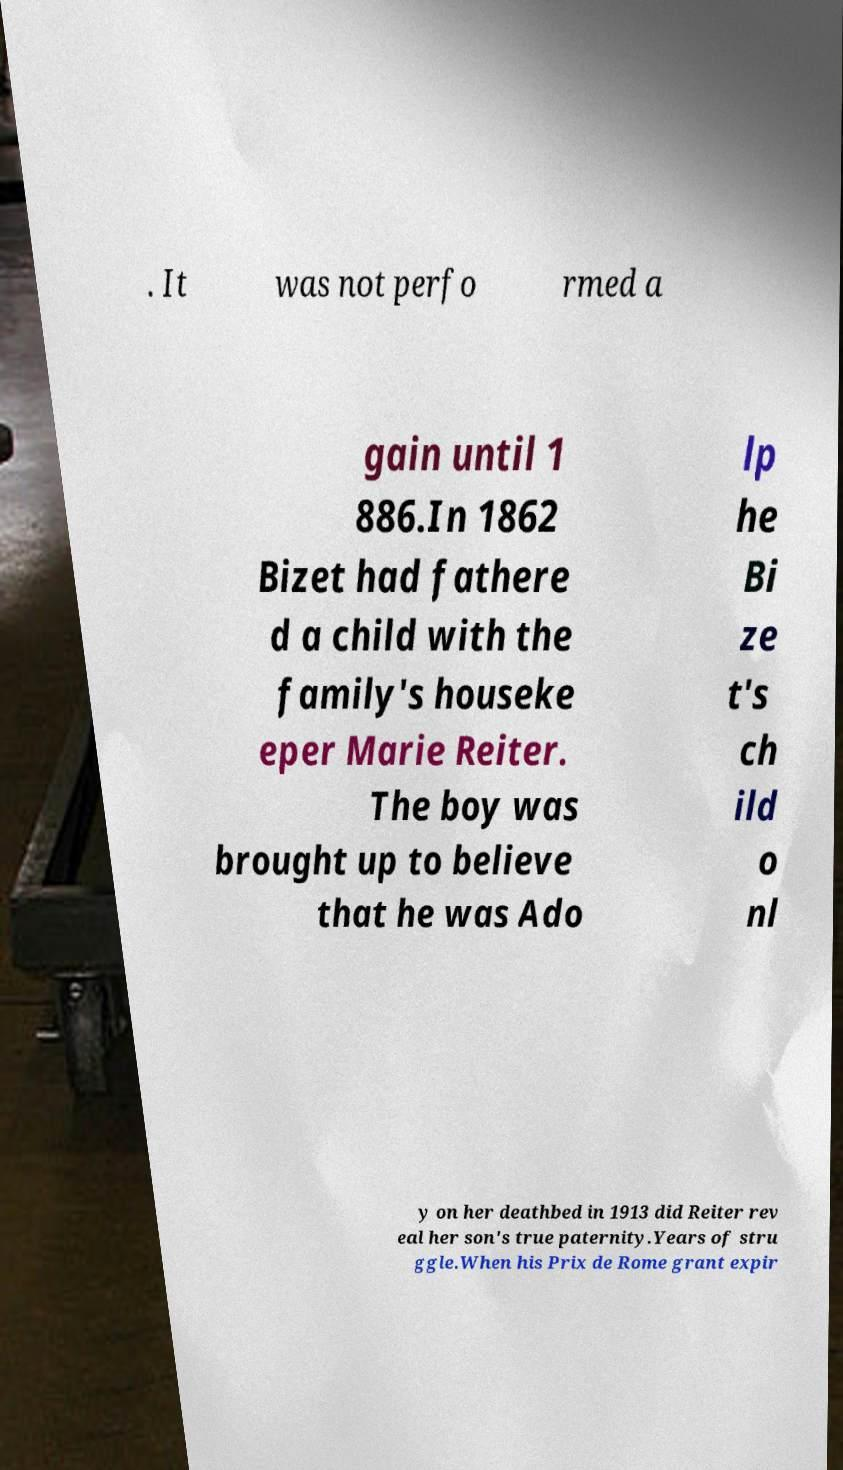For documentation purposes, I need the text within this image transcribed. Could you provide that? . It was not perfo rmed a gain until 1 886.In 1862 Bizet had fathere d a child with the family's houseke eper Marie Reiter. The boy was brought up to believe that he was Ado lp he Bi ze t's ch ild o nl y on her deathbed in 1913 did Reiter rev eal her son's true paternity.Years of stru ggle.When his Prix de Rome grant expir 